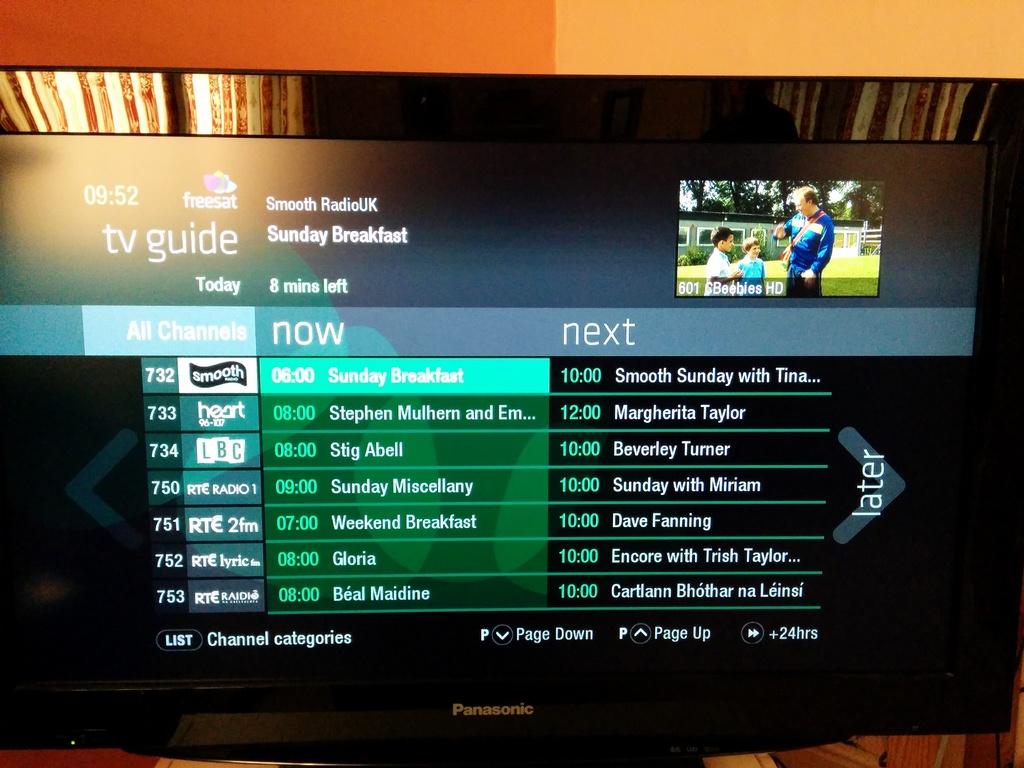What shows are playing now?
Keep it short and to the point. Sunday breakfast. 